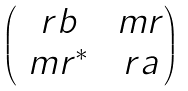Convert formula to latex. <formula><loc_0><loc_0><loc_500><loc_500>\begin{pmatrix} \ r b & \ m r \\ \ m r ^ { * } & \ r a \end{pmatrix}</formula> 